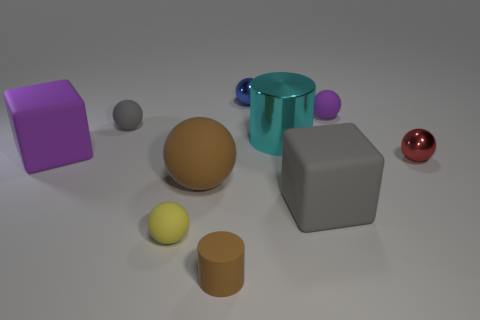What is the color of the tiny matte object that is behind the yellow ball and on the right side of the gray ball?
Give a very brief answer. Purple. There is a gray rubber object that is behind the red shiny object; is its shape the same as the purple rubber thing behind the purple rubber cube?
Keep it short and to the point. Yes. There is a cylinder behind the small red ball; what is it made of?
Make the answer very short. Metal. What size is the matte cylinder that is the same color as the big rubber ball?
Your answer should be compact. Small. What number of objects are objects to the right of the tiny blue shiny object or large cylinders?
Offer a terse response. 4. Are there the same number of small rubber objects behind the purple cube and metal spheres?
Make the answer very short. Yes. Is the size of the red sphere the same as the cyan shiny object?
Keep it short and to the point. No. The rubber cylinder that is the same size as the purple matte ball is what color?
Offer a very short reply. Brown. Does the purple sphere have the same size as the block that is to the left of the big gray rubber block?
Provide a succinct answer. No. What number of small objects are the same color as the large metal object?
Your response must be concise. 0. 